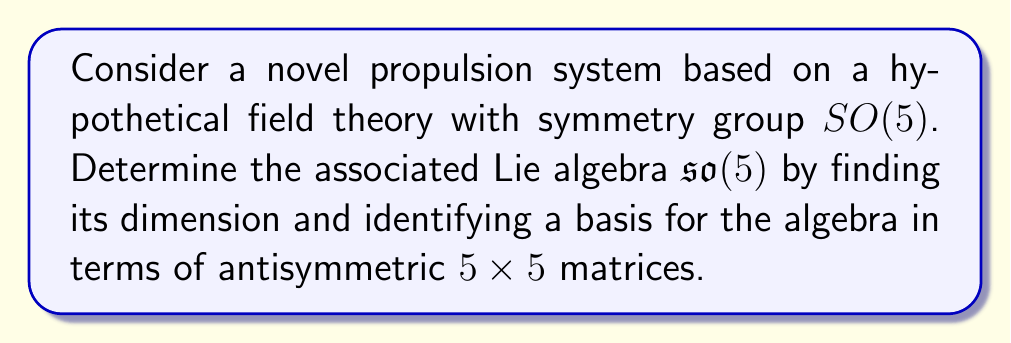Provide a solution to this math problem. To determine the Lie algebra $\mathfrak{so}(5)$ associated with the symmetry group $SO(5)$ of our propulsion system, we follow these steps:

1) Dimension of $\mathfrak{so}(5)$:
   The dimension of $\mathfrak{so}(n)$ is given by the formula $\frac{n(n-1)}{2}$.
   For $n=5$: $\dim(\mathfrak{so}(5)) = \frac{5(5-1)}{2} = \frac{5 \cdot 4}{2} = 10$

2) Basis of $\mathfrak{so}(5)$:
   The Lie algebra $\mathfrak{so}(5)$ consists of $5 \times 5$ antisymmetric matrices. We can construct a basis by creating matrices with 1 in the $(i,j)$ position, -1 in the $(j,i)$ position, and 0 elsewhere, for $1 \leq i < j \leq 5$.

   Let $E_{ij}$ denote the matrix with 1 in the $(i,j)$ position and 0 elsewhere. Then, a basis for $\mathfrak{so}(5)$ is given by:

   $$X_{ij} = E_{ij} - E_{ji}, \quad 1 \leq i < j \leq 5$$

   Explicitly, the ten basis elements are:

   $$X_{12} = \begin{pmatrix}
   0 & 1 & 0 & 0 & 0 \\
   -1 & 0 & 0 & 0 & 0 \\
   0 & 0 & 0 & 0 & 0 \\
   0 & 0 & 0 & 0 & 0 \\
   0 & 0 & 0 & 0 & 0
   \end{pmatrix}, \quad
   X_{13} = \begin{pmatrix}
   0 & 0 & 1 & 0 & 0 \\
   0 & 0 & 0 & 0 & 0 \\
   -1 & 0 & 0 & 0 & 0 \\
   0 & 0 & 0 & 0 & 0 \\
   0 & 0 & 0 & 0 & 0
   \end{pmatrix}, \quad \ldots, \quad
   X_{45} = \begin{pmatrix}
   0 & 0 & 0 & 0 & 0 \\
   0 & 0 & 0 & 0 & 0 \\
   0 & 0 & 0 & 0 & 0 \\
   0 & 0 & 0 & 0 & 1 \\
   0 & 0 & 0 & -1 & 0
   \end{pmatrix}$$

   These matrices form a basis for $\mathfrak{so}(5)$ and can be used to describe the infinitesimal symmetries of the propulsion system.
Answer: The Lie algebra $\mathfrak{so}(5)$ associated with the $SO(5)$ symmetry group of the propulsion system has dimension 10. A basis for $\mathfrak{so}(5)$ is given by the set of antisymmetric $5 \times 5$ matrices $\{X_{ij} = E_{ij} - E_{ji} \mid 1 \leq i < j \leq 5\}$, where $E_{ij}$ is the matrix with 1 in the $(i,j)$ position and 0 elsewhere. 